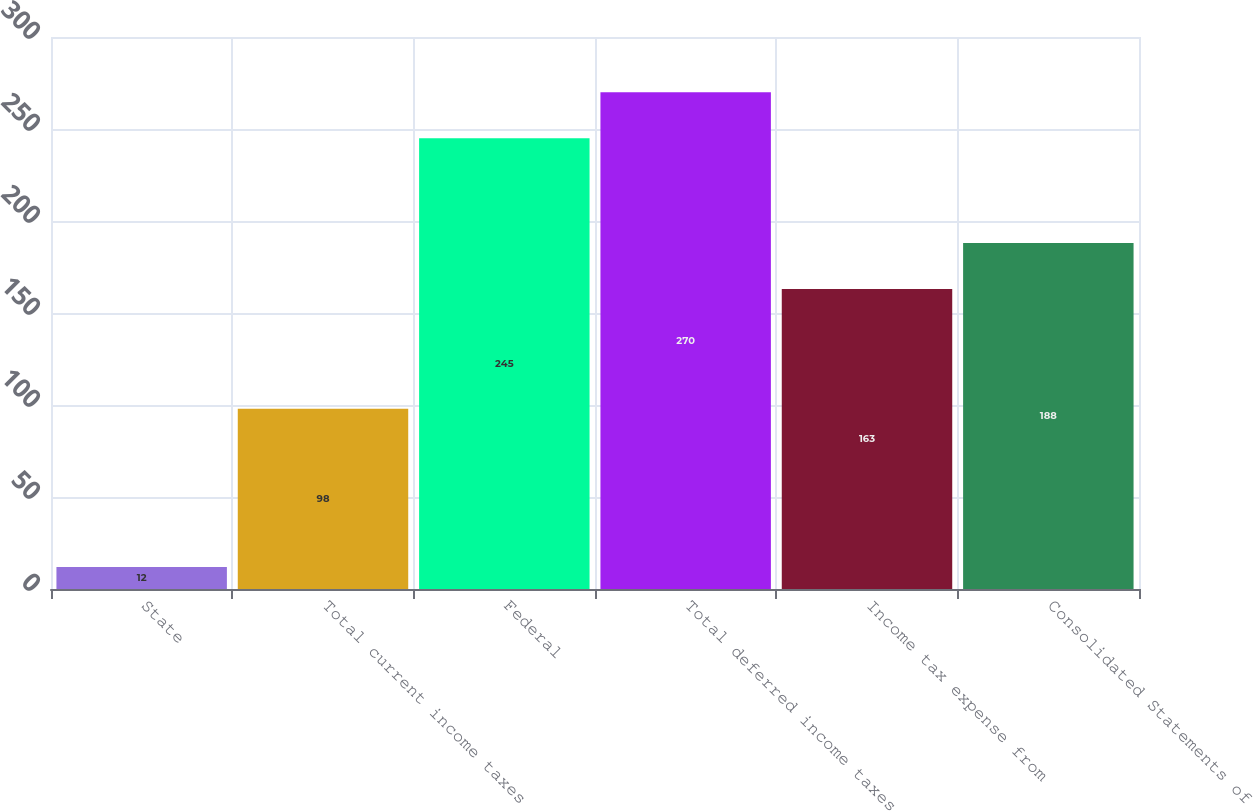<chart> <loc_0><loc_0><loc_500><loc_500><bar_chart><fcel>State<fcel>Total current income taxes<fcel>Federal<fcel>Total deferred income taxes<fcel>Income tax expense from<fcel>Consolidated Statements of<nl><fcel>12<fcel>98<fcel>245<fcel>270<fcel>163<fcel>188<nl></chart> 